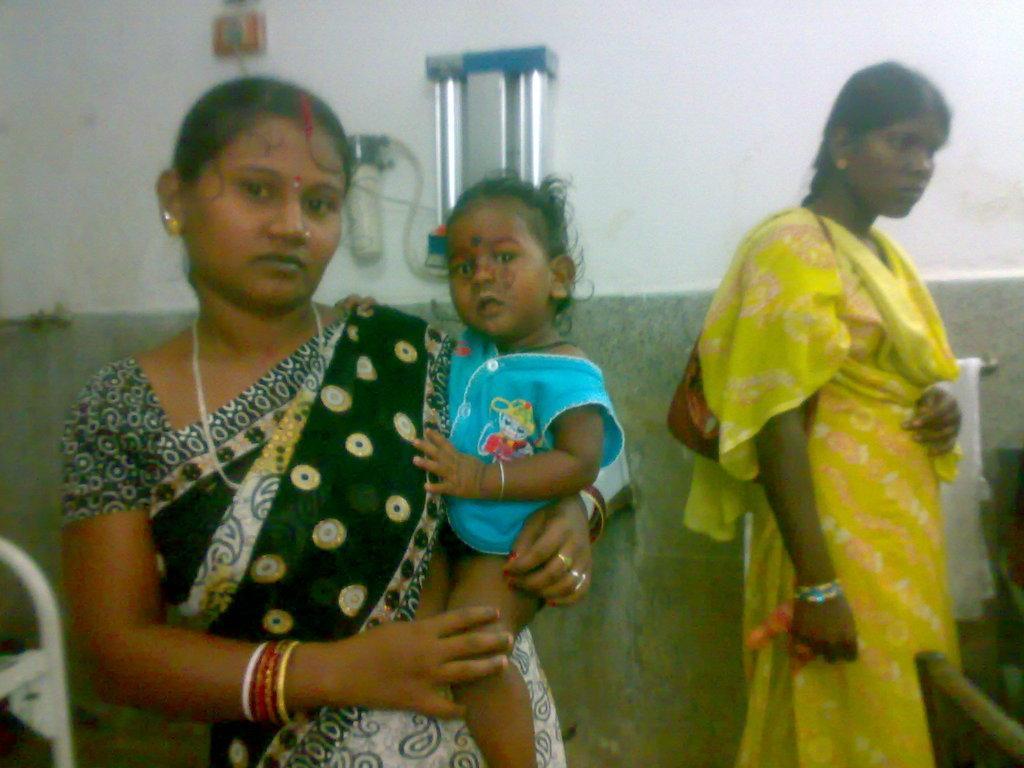How would you summarize this image in a sentence or two? In this image there are persons standing. The woman in the front is standing and holding a baby and in the background there is a machine fixed on the wall. On the left side there is a bed which is white in colour. On the right side there is a towel hanging on the wall. 